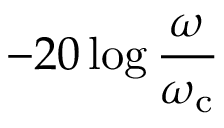<formula> <loc_0><loc_0><loc_500><loc_500>- 2 0 \log { \frac { \omega } { \omega _ { c } } }</formula> 